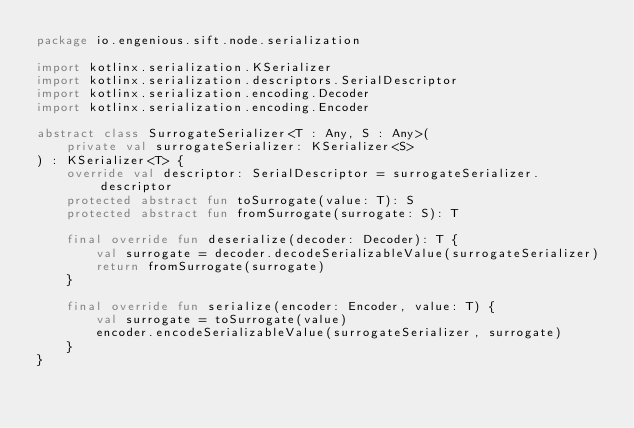Convert code to text. <code><loc_0><loc_0><loc_500><loc_500><_Kotlin_>package io.engenious.sift.node.serialization

import kotlinx.serialization.KSerializer
import kotlinx.serialization.descriptors.SerialDescriptor
import kotlinx.serialization.encoding.Decoder
import kotlinx.serialization.encoding.Encoder

abstract class SurrogateSerializer<T : Any, S : Any>(
    private val surrogateSerializer: KSerializer<S>
) : KSerializer<T> {
    override val descriptor: SerialDescriptor = surrogateSerializer.descriptor
    protected abstract fun toSurrogate(value: T): S
    protected abstract fun fromSurrogate(surrogate: S): T

    final override fun deserialize(decoder: Decoder): T {
        val surrogate = decoder.decodeSerializableValue(surrogateSerializer)
        return fromSurrogate(surrogate)
    }

    final override fun serialize(encoder: Encoder, value: T) {
        val surrogate = toSurrogate(value)
        encoder.encodeSerializableValue(surrogateSerializer, surrogate)
    }
}
</code> 